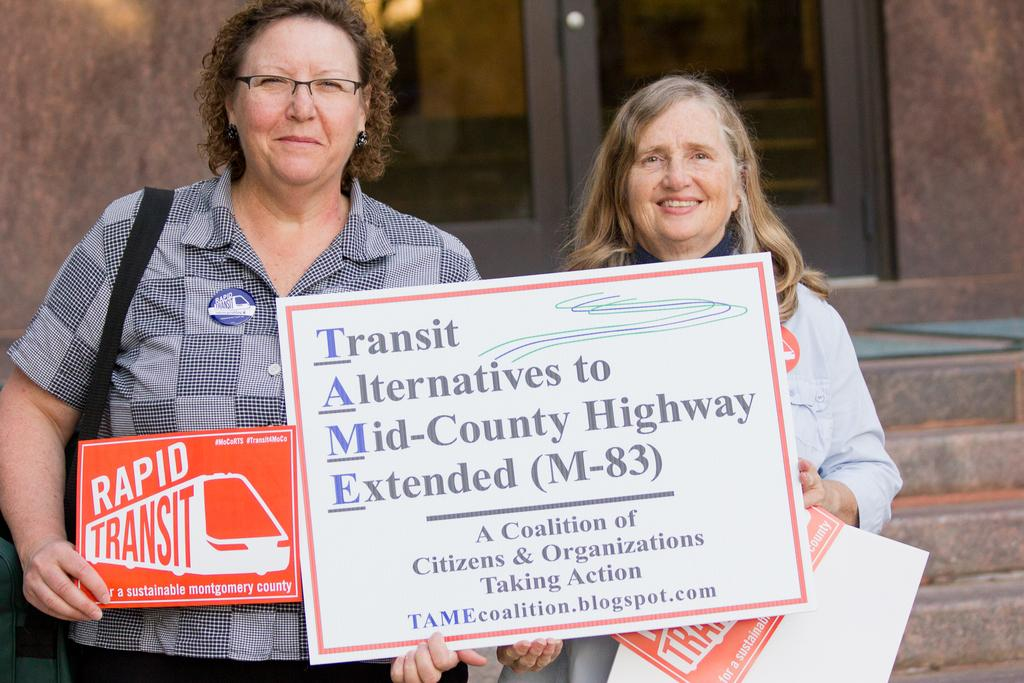How many people are in the image? There are two women in the image. What are the women doing in the image? The women are standing and holding boards in their hands. What can be seen in the background of the image? There is a building, stairs, and a glass door in the background of the image. What type of holiday is being celebrated by the band in the image? There is no band present in the image, and therefore no holiday can be associated with it. 